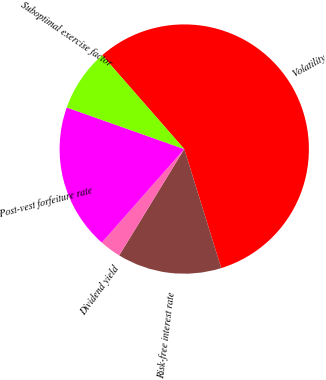<chart> <loc_0><loc_0><loc_500><loc_500><pie_chart><fcel>Volatility<fcel>Risk-free interest rate<fcel>Dividend yield<fcel>Post-vest forfeiture rate<fcel>Suboptimal exercise factor<nl><fcel>56.64%<fcel>13.53%<fcel>2.76%<fcel>18.92%<fcel>8.15%<nl></chart> 